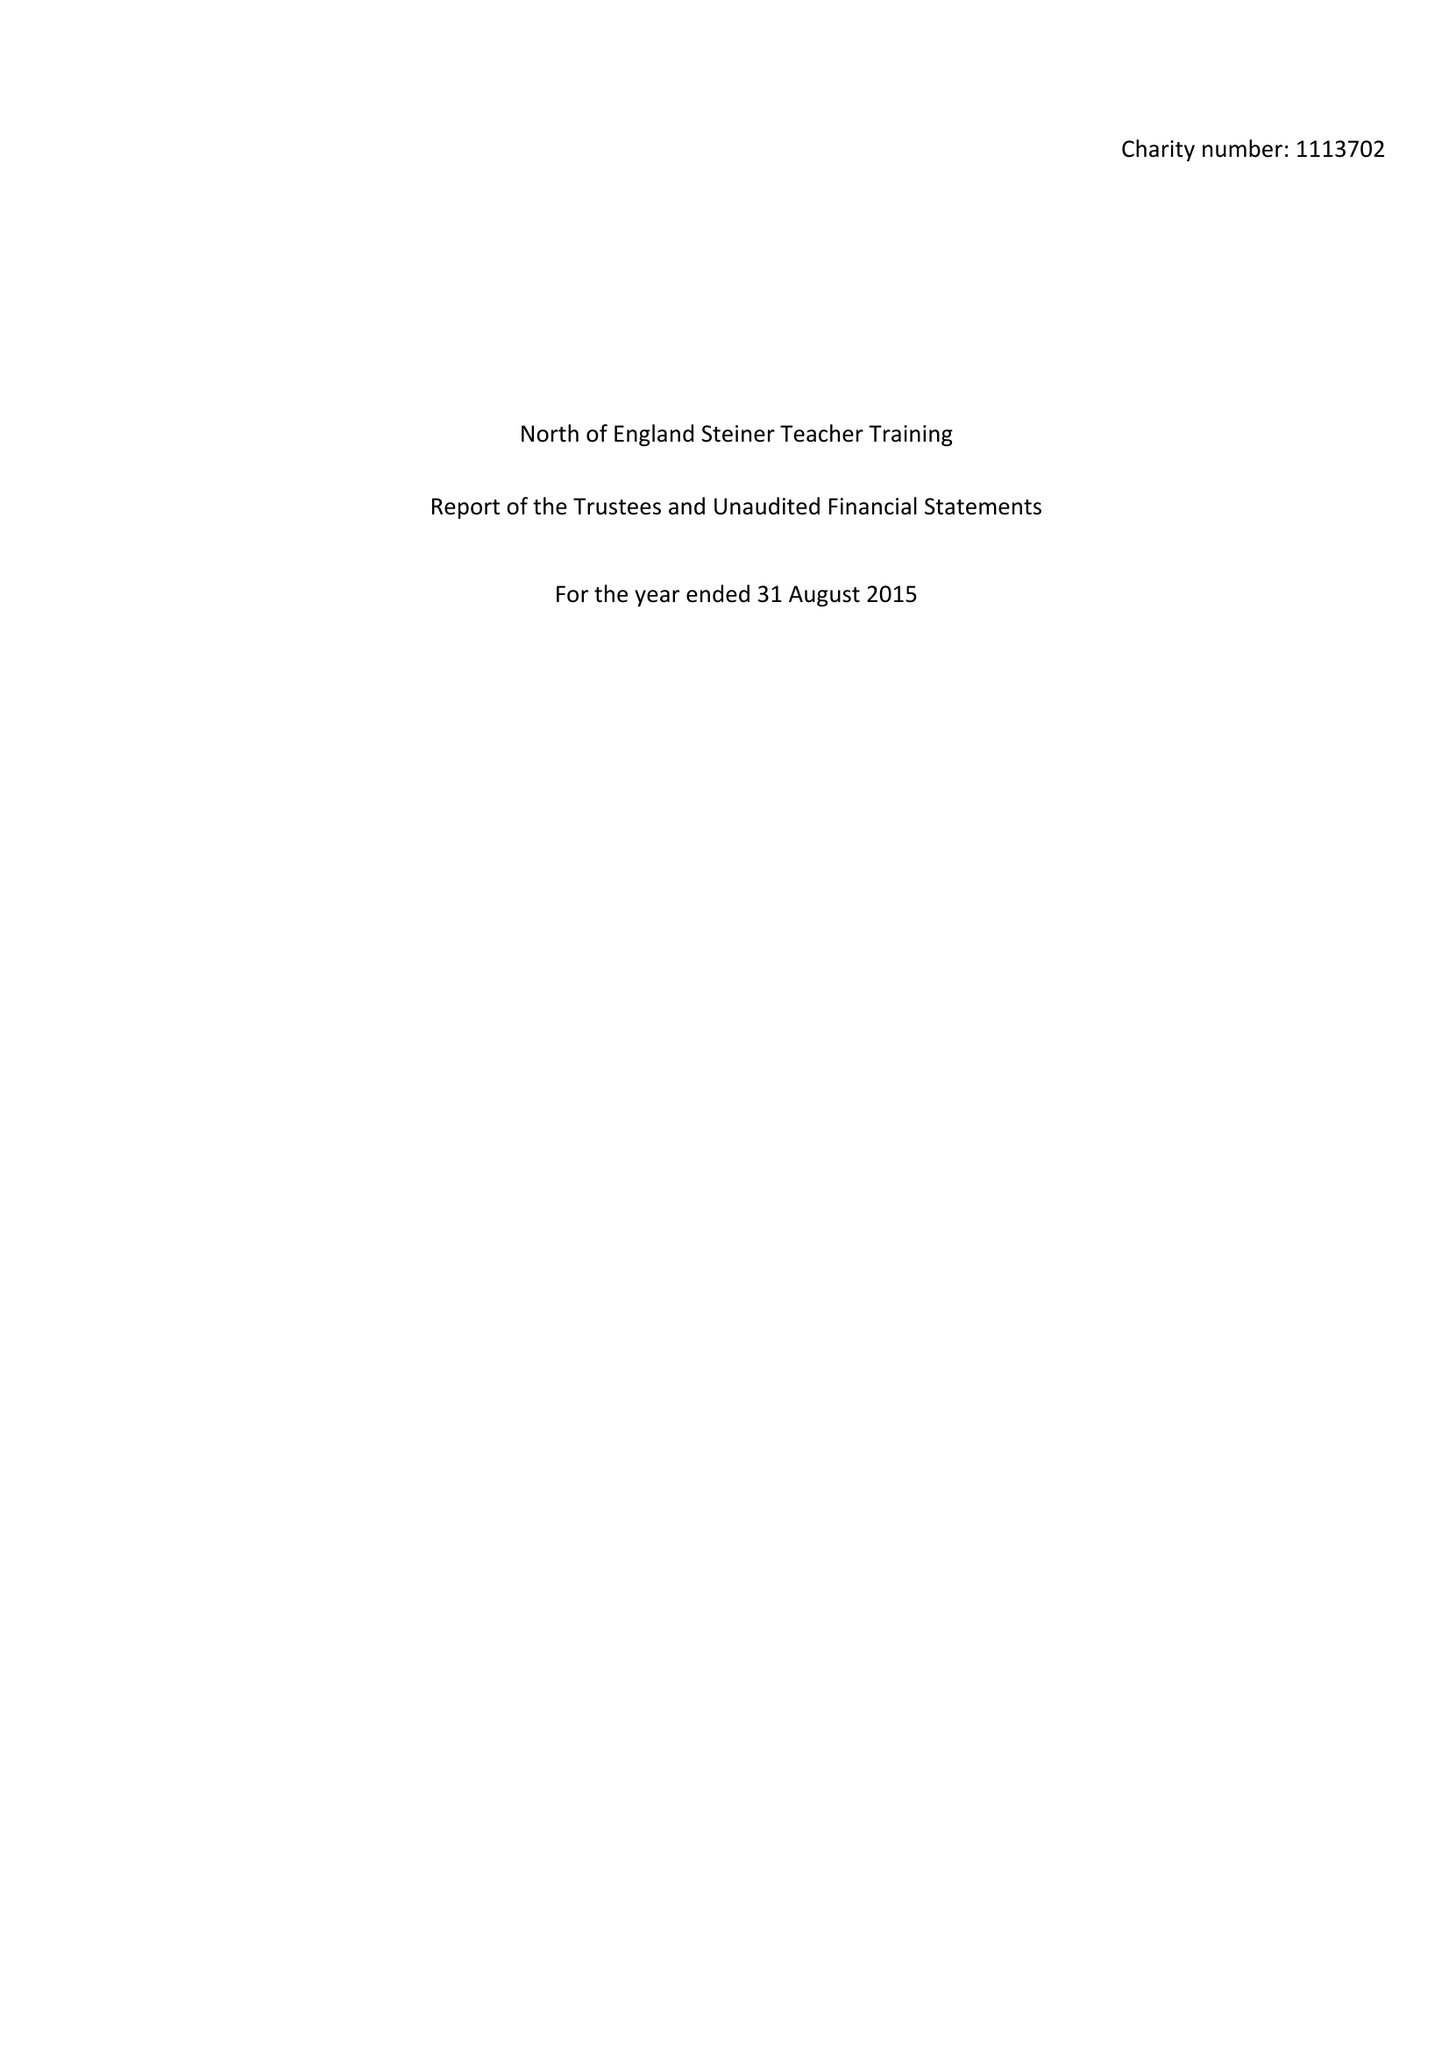What is the value for the charity_number?
Answer the question using a single word or phrase. 1113702 